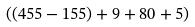Convert formula to latex. <formula><loc_0><loc_0><loc_500><loc_500>( ( 4 5 5 - 1 5 5 ) + 9 + 8 0 + 5 )</formula> 